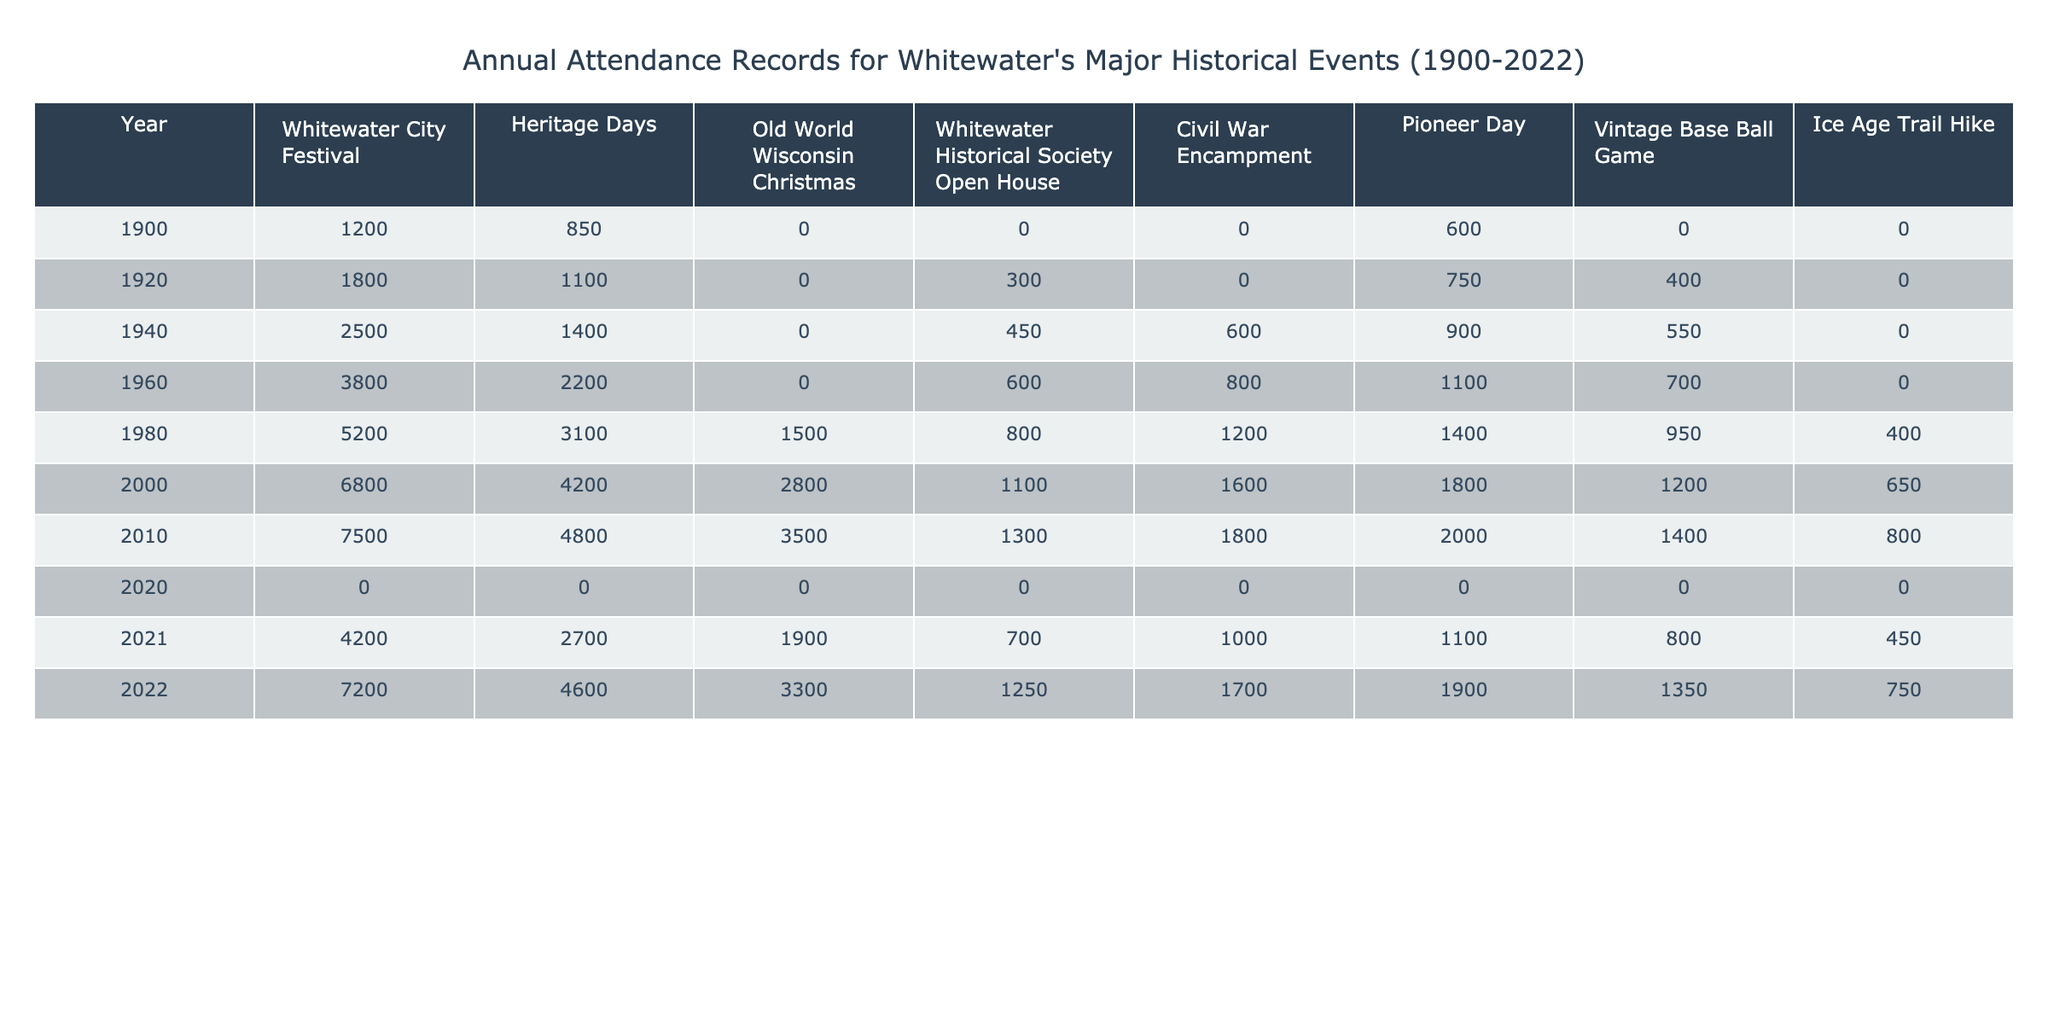What was the attendance at the Whitewater City Festival in 1960? The table shows that the attendance at the Whitewater City Festival in 1960 was 3800.
Answer: 3800 What is the average attendance for Heritage Days from 1900 to 2022? The attendances for Heritage Days over the years are 850, 1100, 1400, 2200, 3100, 4200, 4800, 2700, and 4600. Summing these values gives 19000. There are 9 data points, so the average is 19000/9 ≈ 2111.11.
Answer: Approximately 2111 Was there any attendance recorded for the Old World Wisconsin Christmas event in 1900? The table indicates that there is no attendance data for the Old World Wisconsin Christmas event in 1900, showing 'N/A.'
Answer: No What was the highest recorded attendance for Pioneer Day and in which year did it occur? The attendances for Pioneer Day are 600, 1200, 1100, 1400, 1800, 1000, and 1700. The highest value is 1800, which occurred in the year 2000.
Answer: 1800 in 2000 How much did the attendance for the Vintage Base Ball Game change between 1980 and 2022? The attendance for the Vintage Base Ball Game in 1980 was 950, and in 2022 it was 1350. To find the change, subtract 950 from 1350, which gives 400.
Answer: Increased by 400 In which decade did the Whitewater Historical Society Open House see its highest attendance? The attendances for the Whitewater Historical Society Open House from the years provided are 0 in 1900, 300 in 1920, 450 in 1940, 600 in 1960, 800 in 1980, 1100 in 2000, 1300 in 2010, 700 in 2021, and 1250 in 2022. The highest attendance was 1300 in 2010, which is in the 2010s decade.
Answer: 2010s What trends can be observed in attendance for the Civil War Encampment from 2000 to 2022? The attendance for the Civil War Encampment shows values of 1600 in 2000, 1800 in 2010, 1000 in 2021, and 1700 in 2022. The trend indicates a peak in 2010, followed by a decline to 1000 and then an increase to 1700 in 2022.
Answer: Fluctuating attendance, peak in 2010 Was the overall attendance for all events higher in 2022 or in 2000? Adding the attendances for all events in 2000: 6800 + 4200 + 2800 + 1100 + 1600 + 1800 + 1200 + 650 = 18850. For 2022: 7200 + 4600 + 3300 + 1250 + 1700 + 1900 + 1350 + 750 = 19550. Comparing these sums shows that attendance in 2022 (19550) is higher than in 2000 (18850).
Answer: Higher in 2022 What percentage of the total attendance in 2021 came from the Whitewater City Festival? The total attendance for all events in 2021 is 4200 + 2700 + 1900 + 700 + 1000 + 1100 + 800 + 450 = 14500. The Whitewater City Festival attendance in 2021 is 4200. To find the percentage: (4200/14500) * 100 ≈ 28.97%.
Answer: Approximately 28.97% 